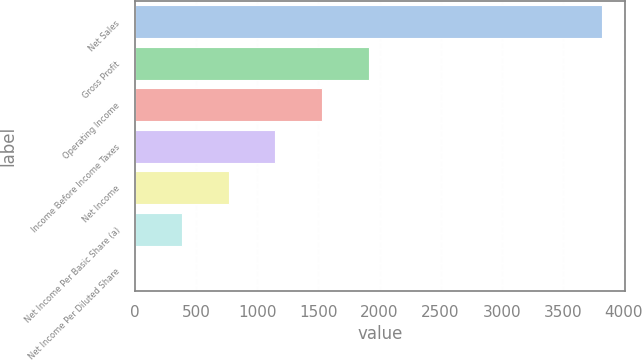Convert chart. <chart><loc_0><loc_0><loc_500><loc_500><bar_chart><fcel>Net Sales<fcel>Gross Profit<fcel>Operating Income<fcel>Income Before Income Taxes<fcel>Net Income<fcel>Net Income Per Basic Share (a)<fcel>Net Income Per Diluted Share<nl><fcel>3818<fcel>1909.82<fcel>1528.18<fcel>1146.55<fcel>764.91<fcel>383.28<fcel>1.65<nl></chart> 